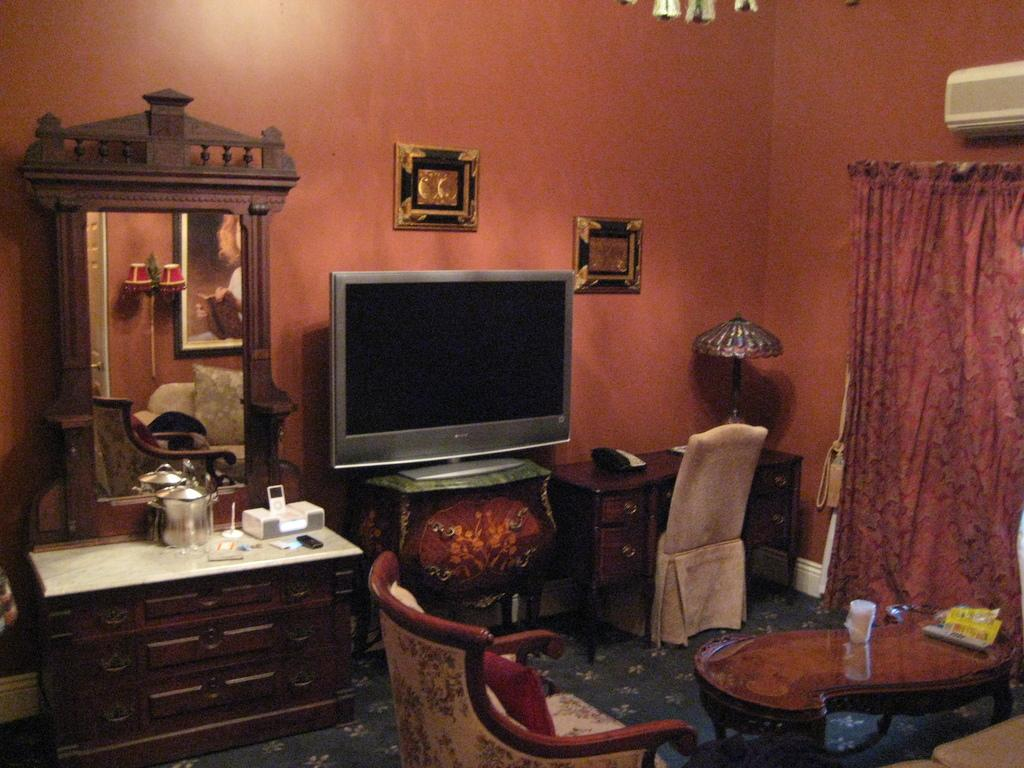Where is the setting of the image? The image is inside a room. What electronic device can be seen in the room? There is a television in the room. What type of furniture is present in the room? There is a sofa set and a table in the room. What is used for personal grooming in the room? There is a dressing table in the room. What type of window treatment is present in the room? There are curtains in the room. How is the room cooled? There is an air conditioner in the room. What type of decorative items are present on the wall? There are photo frames attached to a wall in the room. What type of bean is being used to invent a new recipe in the image? There is no bean or recipe creation present in the image. How does the room express its dislike for a particular person in the image? The room does not express any emotions or opinions, as it is an inanimate object. 